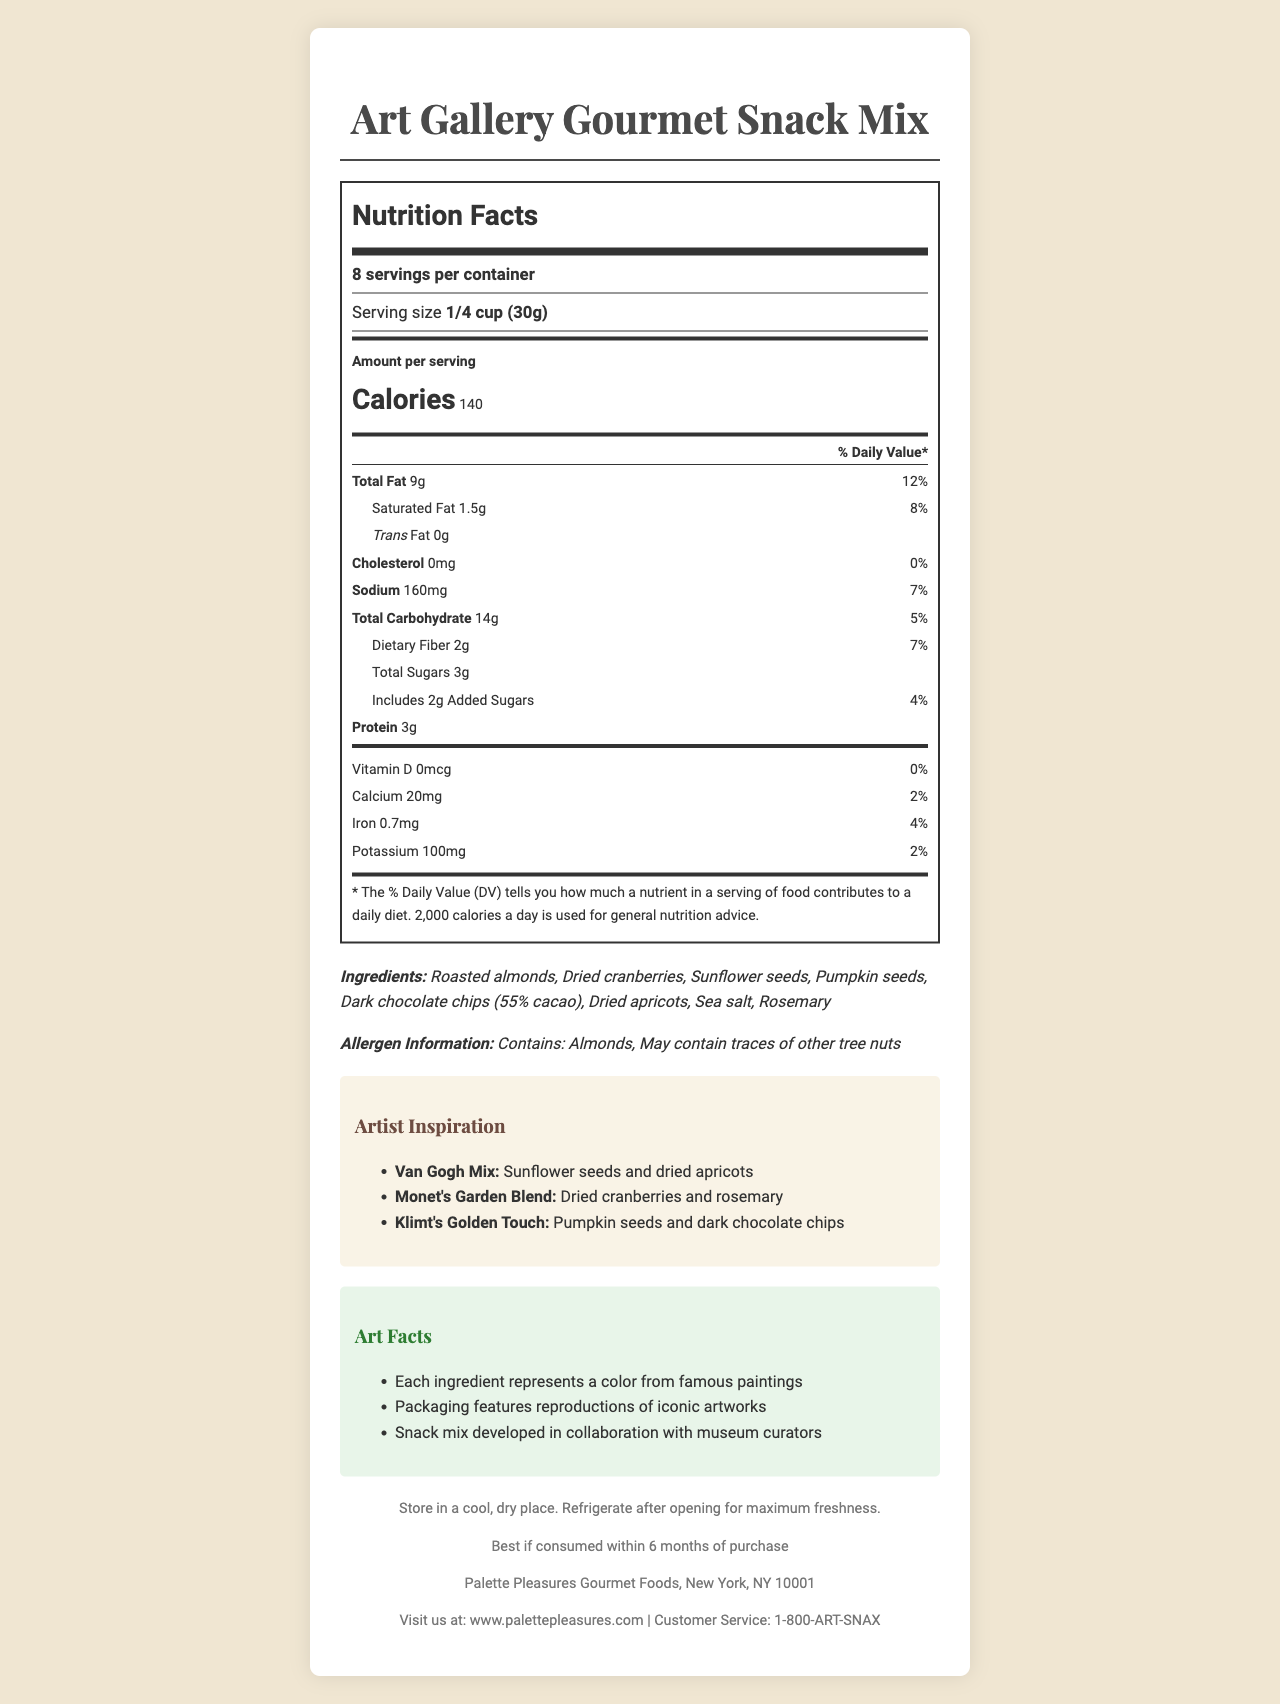what is the serving size? The serving size is listed in the document as "1/4 cup (30g)".
Answer: 1/4 cup (30g) how many servings per container are there? The document states there are 8 servings per container.
Answer: 8 servings per container what is the total calorie count per serving? The document specifies that each serving has 140 calories.
Answer: 140 calories which ingredient appears first in the list? The first ingredient listed in the ingredients section is "Roasted almonds".
Answer: Roasted almonds how much saturated fat is in each serving? The saturated fat content per serving is indicated as "1.5g" in the document.
Answer: 1.5g which famous artist inspired a mix that includes sunflower seeds and dried apricots? The artist inspiration section mentions that the Van Gogh Mix includes sunflower seeds and dried apricots.
Answer: Van Gogh Mix does the product contain any trans fat? The document states the trans fat content is "0g".
Answer: No how long is the product best if consumed within, after purchase? The expiration date section mentions it is best if consumed within 6 months of purchase.
Answer: 6 months is rosemary one of the ingredients? The ingredient list includes "Rosemary".
Answer: Yes which nutrient has a daily value of 12%? The total fat has a daily value percentage of 12%.
Answer: Total Fat identify a health claim made in the document. The document does not make any specific health claims.
Answer: None art facts The "Art Facts" section shares these details about how the product relates to famous artworks.
Answer: Each ingredient represents a color from famous paintings. Packaging features reproductions of iconic artworks. Snack mix developed in collaboration with museum curators. who is the manufacturer of this product? The manufacturer is listed as "Palette Pleasures Gourmet Foods, New York, NY 10001".
Answer: Palette Pleasures Gourmet Foods, New York, NY 10001 what is the customer service phone number? The customer service phone number is provided as "1-800-ART-SNAX".
Answer: 1-800-ART-SNAX how much protein is in each serving? A. 2g B. 3g C. 4g D. 5g The protein content per serving is listed as "3g".
Answer: B. 3g which of the following contains 100mg of potassium? A. Van Gogh Mix B. Monet's Garden Blend C. Klimt's Golden Touch D. All of the above The potassium content is listed as 100mg, which applies to the entire snack mix, covering all inspired blends.
Answer: D. All of the above is there vitamin D in the product? The document indicates that the vitamin D content is 0mcg, meaning there is no vitamin D in the product.
Answer: No briefly describe the main idea of the document. The document offers detailed nutritional facts, ingredients, artistic inspiration from famous artists, storage instructions, and manufacturer contact information.
Answer: The main idea of the document is to provide comprehensive nutritional information, ingredients, allergen details, and artistic inspiration behind the Art Gallery Gourmet Snack Mix, as well as storage instructions, manufacturing details, and contact information for customer service. how many calories are there in a full container? There are 8 servings per container, each with 140 calories. Multiplying 140 by 8 gives you 1120 calories in a full container.
Answer: 1120 calories who is the curator of the art facts in the document? The document states that the snack mix was developed in collaboration with museum curators but does not specify any names.
Answer: Not enough information 